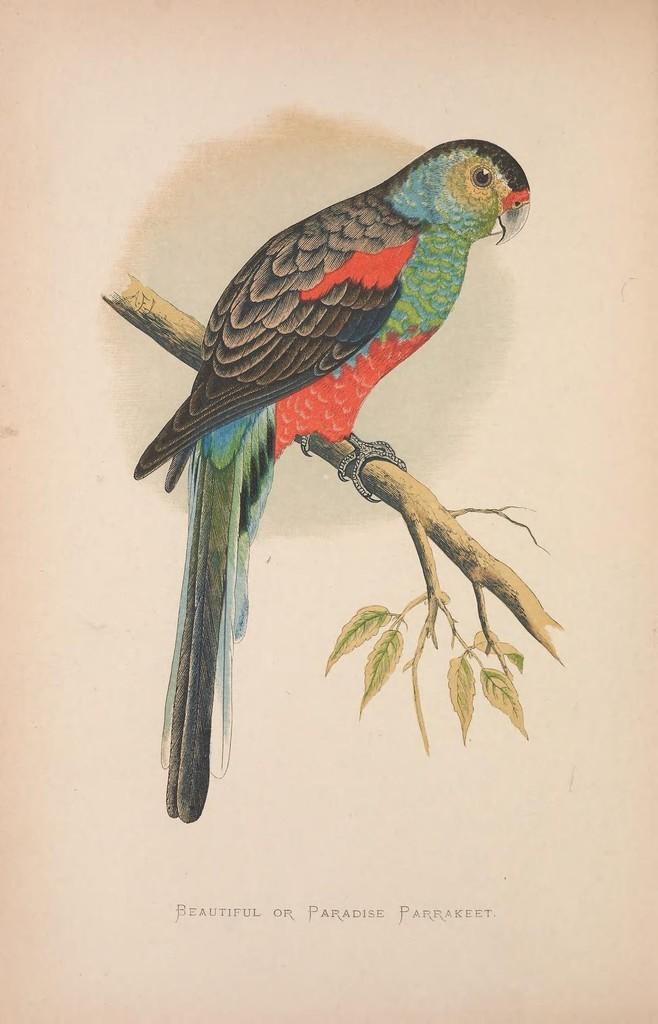What is depicted in the printed image in the picture? There is a printed image of a bird in the picture. Where is the bird located in the image? The bird is on a tree branch in the image. What additional information is provided at the bottom of the image? There is text at the bottom of the image. Can you tell me how many berries are on the tree branch next to the bird in the image? There are no berries present in the image; it only features a bird on a tree branch and text at the bottom. What type of drum is being played by the bird in the image? There is no drum or any musical instrument in the image; it only features a bird on a tree branch and text at the bottom. 